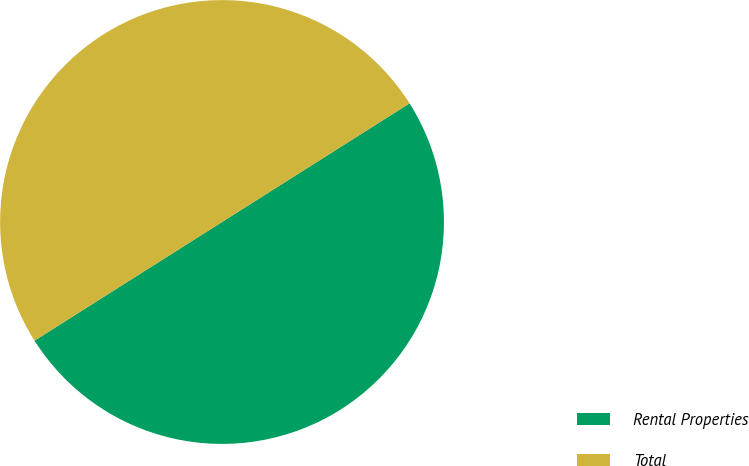<chart> <loc_0><loc_0><loc_500><loc_500><pie_chart><fcel>Rental Properties<fcel>Total<nl><fcel>50.0%<fcel>50.0%<nl></chart> 